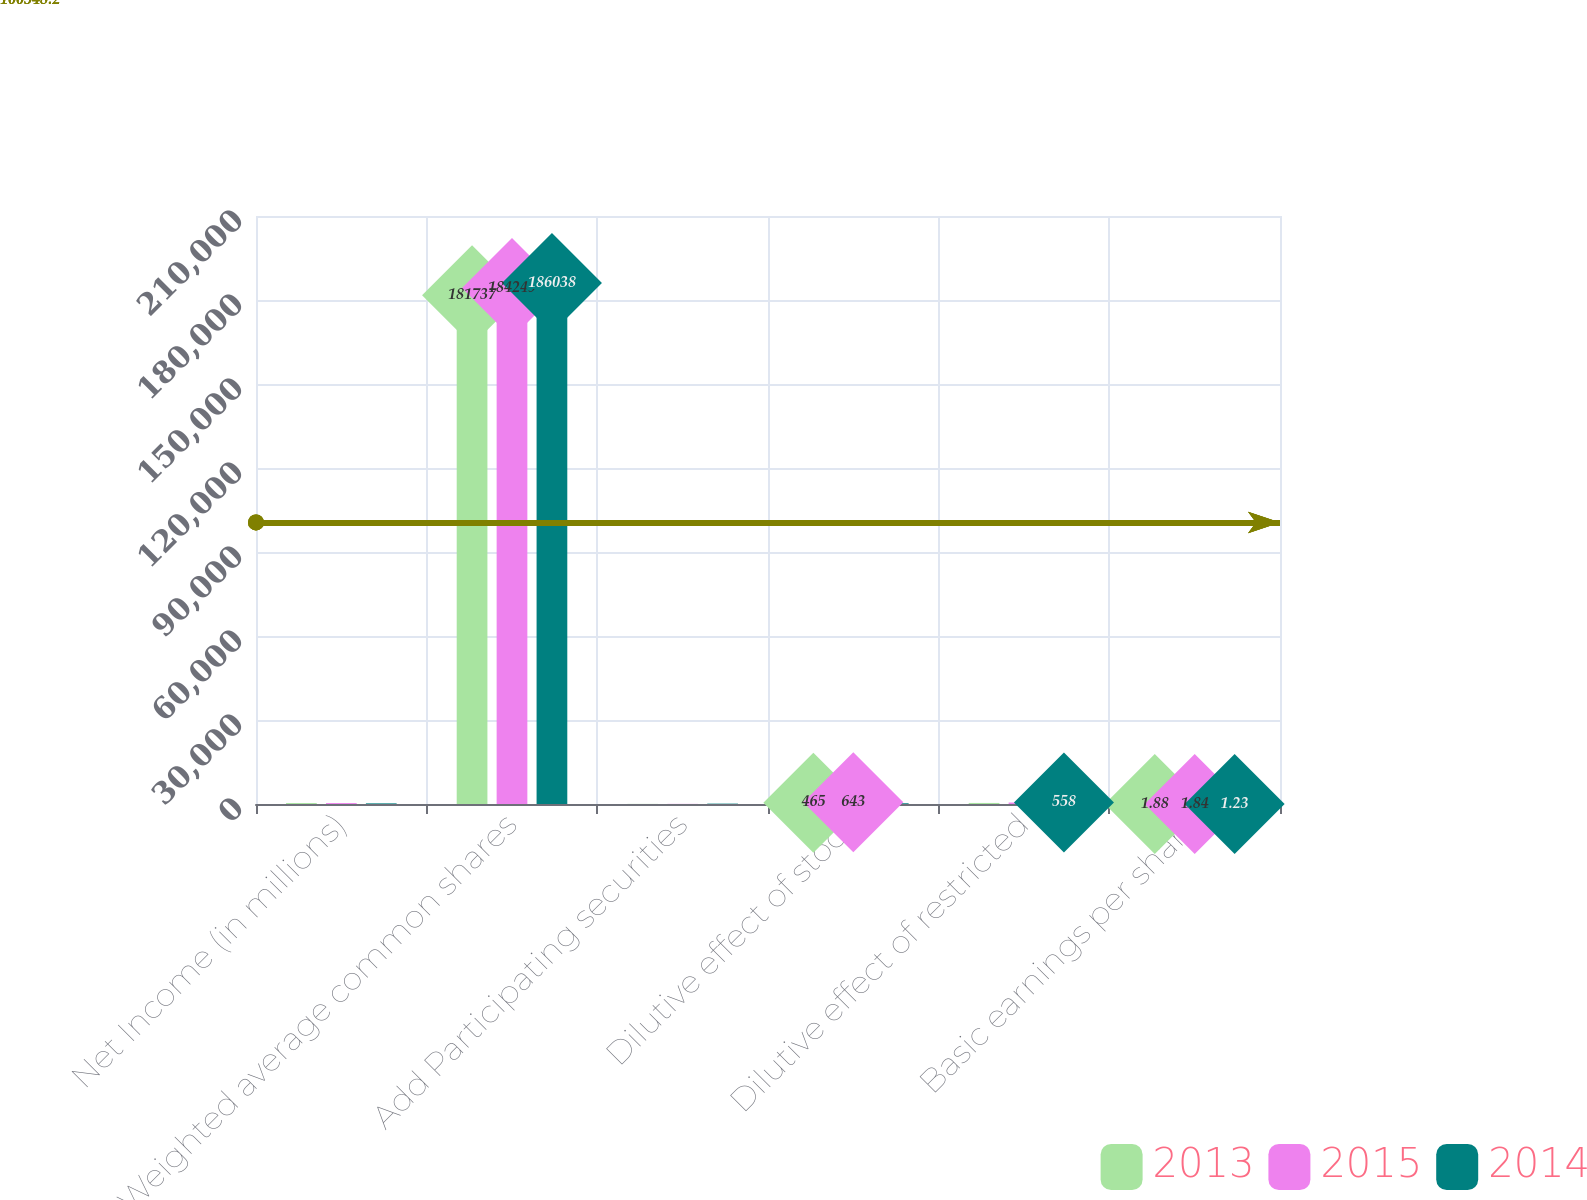Convert chart to OTSL. <chart><loc_0><loc_0><loc_500><loc_500><stacked_bar_chart><ecel><fcel>Net Income (in millions)<fcel>Weighted average common shares<fcel>Add Participating securities<fcel>Dilutive effect of stock<fcel>Dilutive effect of restricted<fcel>Basic earnings per share<nl><fcel>2013<fcel>340<fcel>181737<fcel>39<fcel>465<fcel>379<fcel>1.88<nl><fcel>2015<fcel>337<fcel>184249<fcel>47<fcel>643<fcel>529<fcel>1.84<nl><fcel>2014<fcel>228<fcel>186038<fcel>134<fcel>264<fcel>558<fcel>1.23<nl></chart> 